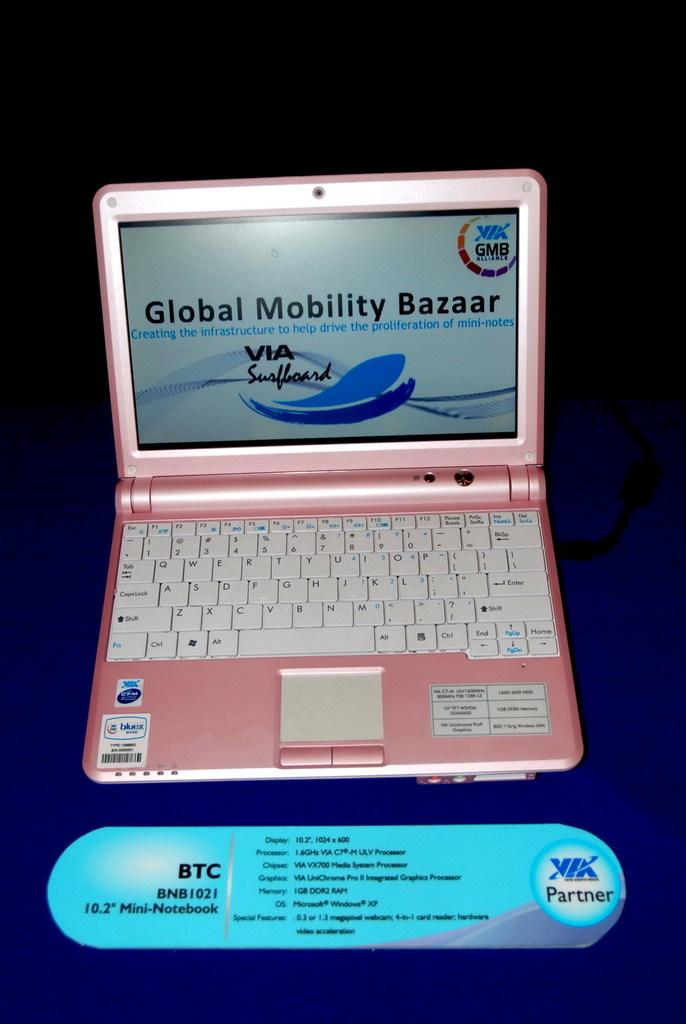<image>
Present a compact description of the photo's key features. A BTC mini notebook computer is sitting on a table opened up and the color is pink. 